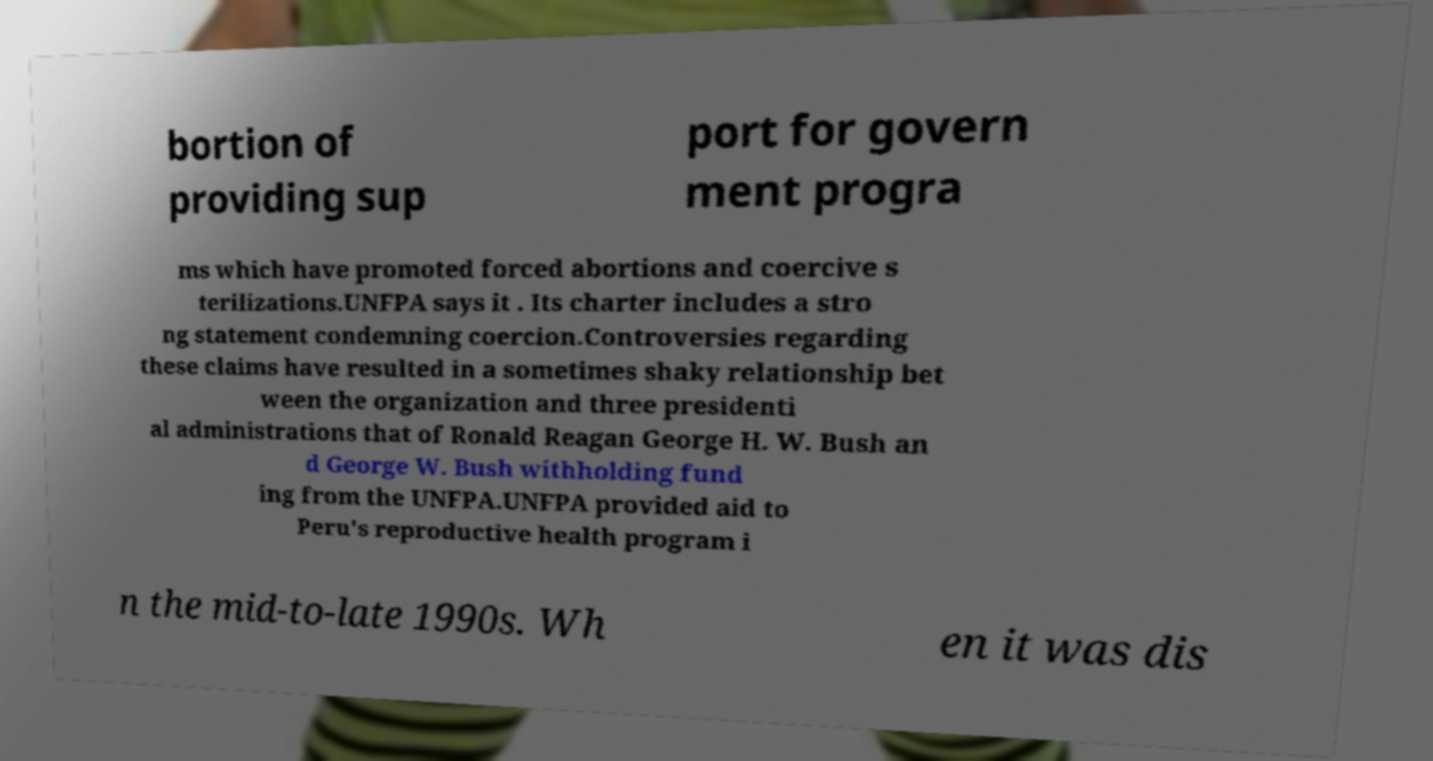Can you read and provide the text displayed in the image?This photo seems to have some interesting text. Can you extract and type it out for me? bortion of providing sup port for govern ment progra ms which have promoted forced abortions and coercive s terilizations.UNFPA says it . Its charter includes a stro ng statement condemning coercion.Controversies regarding these claims have resulted in a sometimes shaky relationship bet ween the organization and three presidenti al administrations that of Ronald Reagan George H. W. Bush an d George W. Bush withholding fund ing from the UNFPA.UNFPA provided aid to Peru's reproductive health program i n the mid-to-late 1990s. Wh en it was dis 